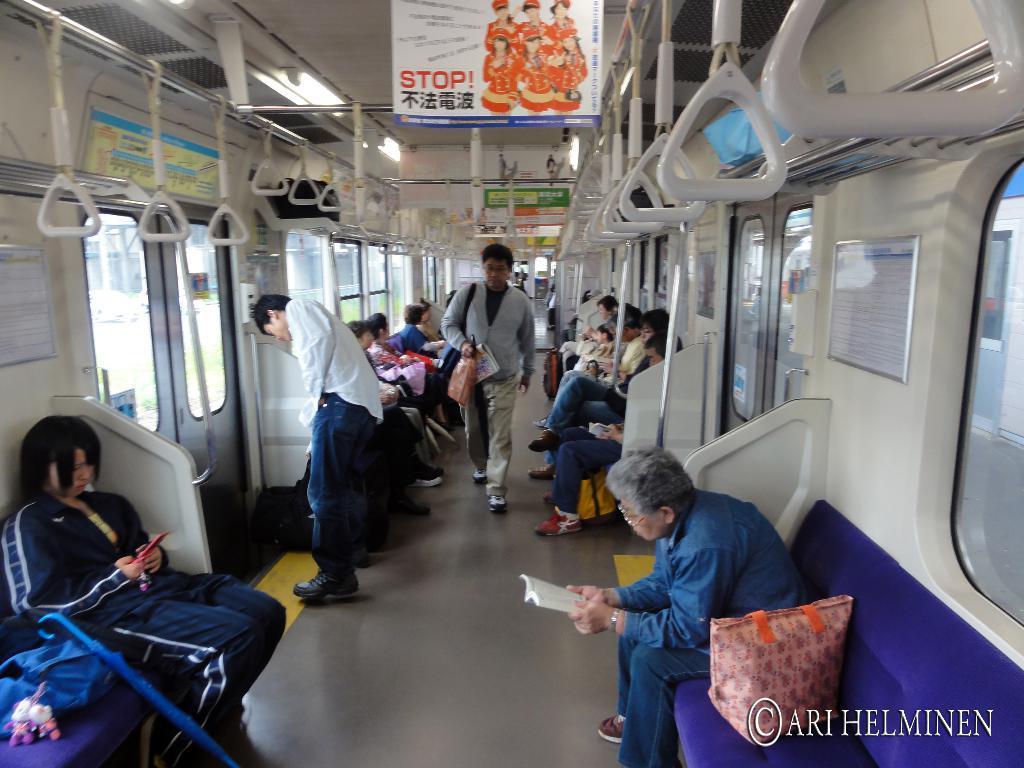Could you give a brief overview of what you see in this image? In this image I can see the interior of the train in which I can see few persons are standing and few persons are sitting. I can see few boards, few lights and few windows of the train. 